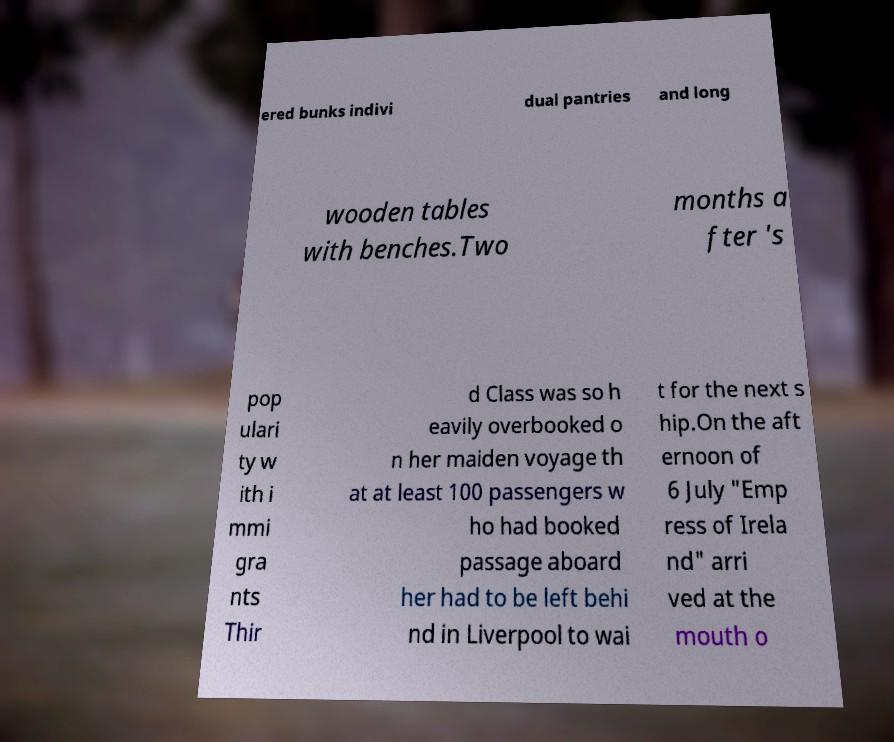For documentation purposes, I need the text within this image transcribed. Could you provide that? ered bunks indivi dual pantries and long wooden tables with benches.Two months a fter 's pop ulari ty w ith i mmi gra nts Thir d Class was so h eavily overbooked o n her maiden voyage th at at least 100 passengers w ho had booked passage aboard her had to be left behi nd in Liverpool to wai t for the next s hip.On the aft ernoon of 6 July "Emp ress of Irela nd" arri ved at the mouth o 